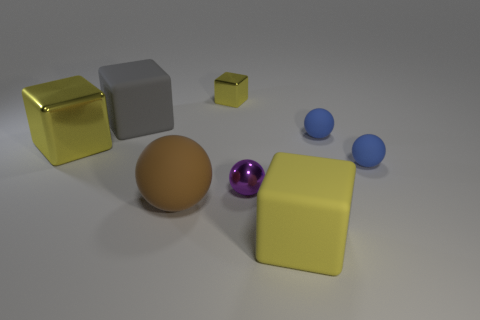There is a rubber thing that is the same color as the tiny block; what size is it?
Offer a terse response. Large. What number of other objects are the same material as the gray cube?
Offer a very short reply. 4. What is the size of the purple metallic ball?
Your response must be concise. Small. How many other things are the same color as the metallic ball?
Provide a succinct answer. 0. What is the color of the metal object that is to the right of the brown object and behind the tiny purple ball?
Your response must be concise. Yellow. What number of tiny blue objects are there?
Ensure brevity in your answer.  2. Do the gray block and the small purple sphere have the same material?
Give a very brief answer. No. There is a yellow metal object that is to the right of the large yellow thing that is behind the big yellow block that is in front of the metal sphere; what shape is it?
Offer a very short reply. Cube. Do the block that is in front of the large brown rubber ball and the yellow thing that is behind the gray matte cube have the same material?
Make the answer very short. No. What is the small cube made of?
Your answer should be compact. Metal. 